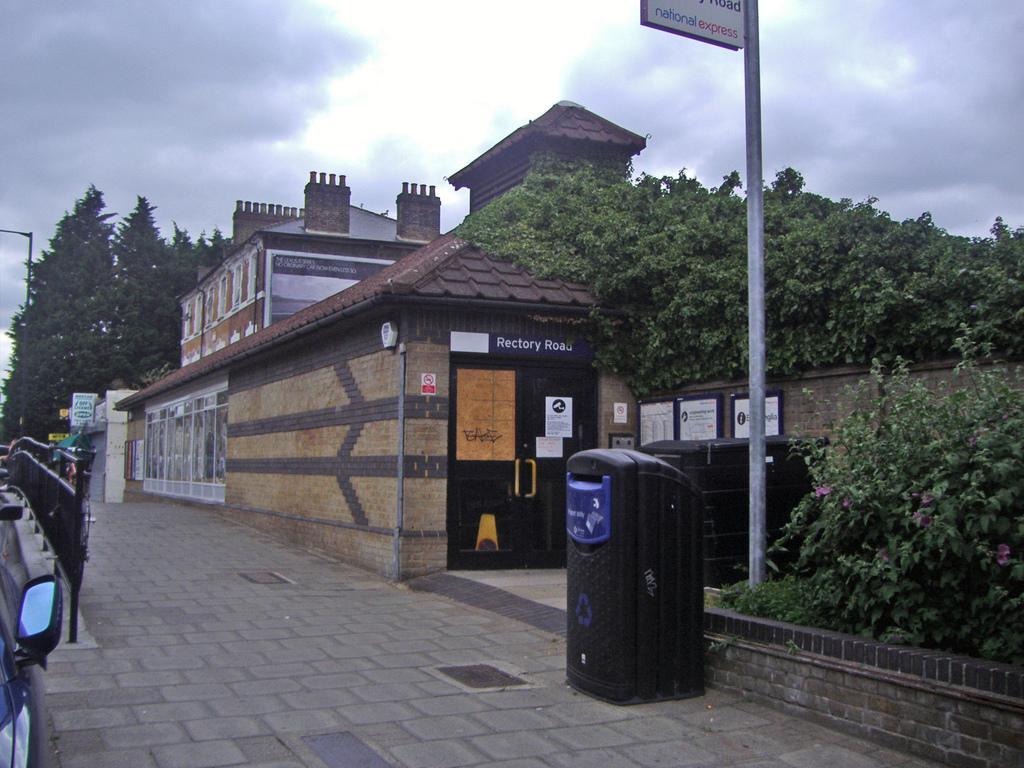Could you give a brief overview of what you see in this image? In this image, we can see houses, trees, walls, posters, doors, poles, dustbin, walkway, plants and flowers. On the left side bottom, corner, we can see a vehicle side mirror. Background we can see the cloudy sky. Here we can see name boards and railing. 